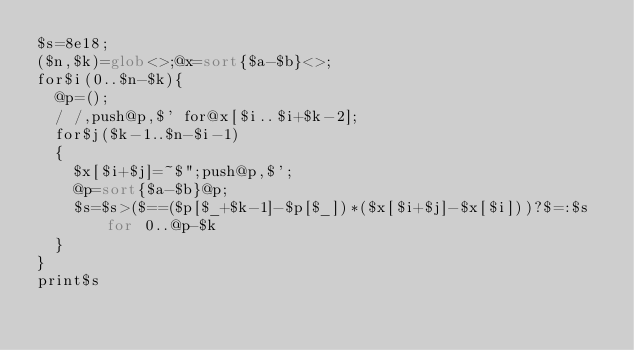Convert code to text. <code><loc_0><loc_0><loc_500><loc_500><_Perl_>$s=8e18;
($n,$k)=glob<>;@x=sort{$a-$b}<>;
for$i(0..$n-$k){
	@p=();
	/ /,push@p,$' for@x[$i..$i+$k-2];
	for$j($k-1..$n-$i-1)
	{
		$x[$i+$j]=~$";push@p,$';
		@p=sort{$a-$b}@p;
		$s=$s>($==($p[$_+$k-1]-$p[$_])*($x[$i+$j]-$x[$i]))?$=:$s for 0..@p-$k
	}
}
print$s
</code> 